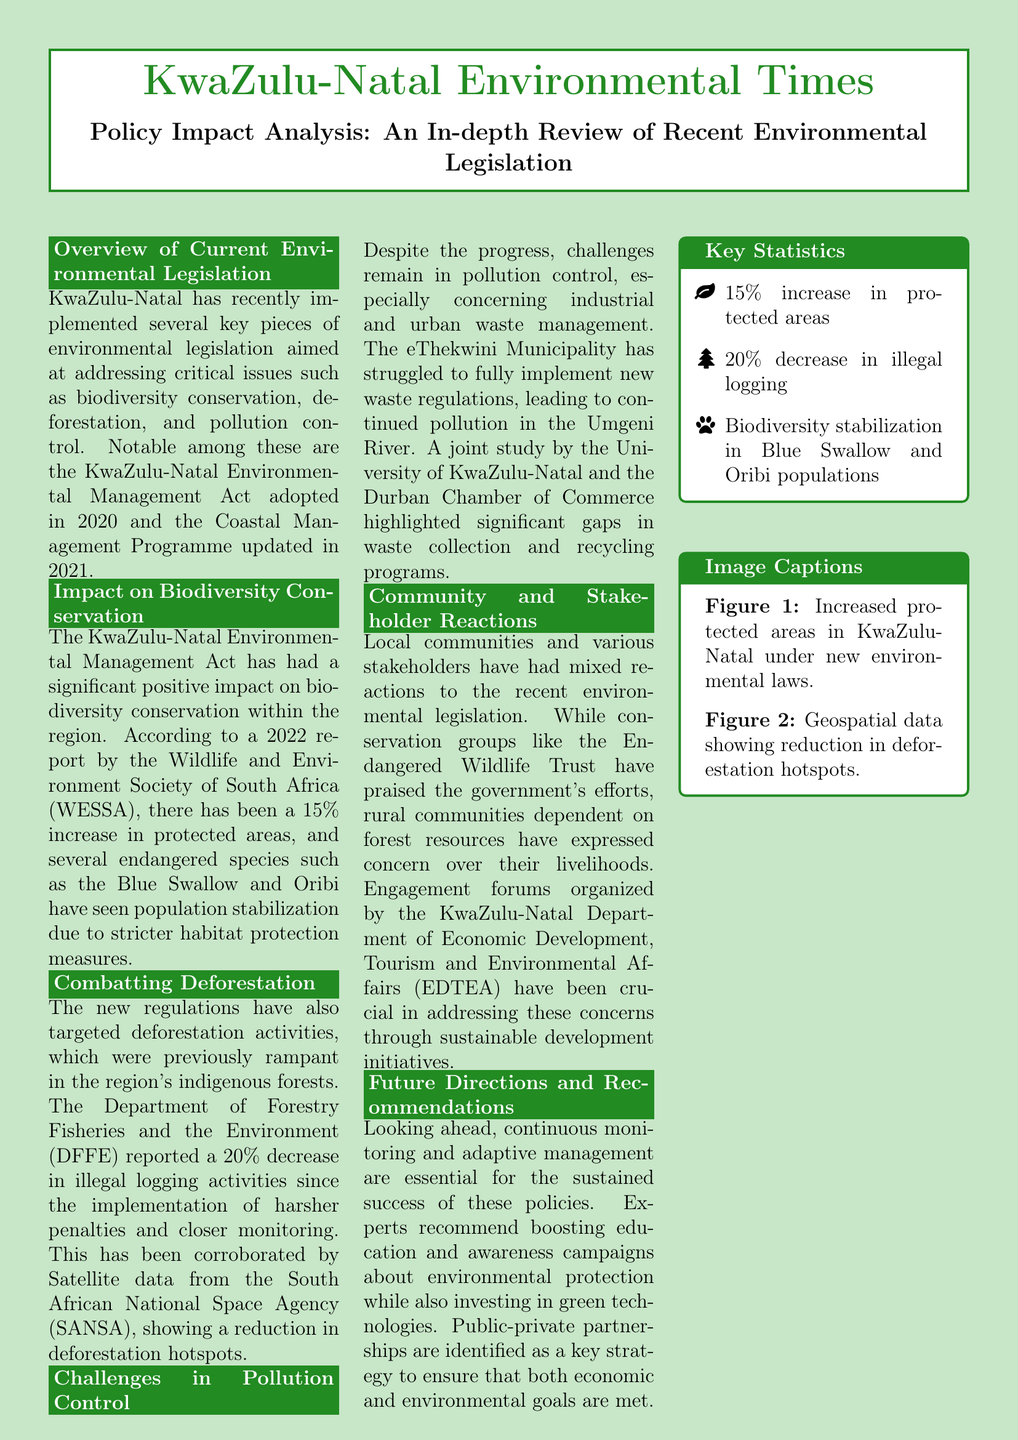What is the title of the analysis? The title of the analysis is found in the introduction section of the document.
Answer: Policy Impact Analysis: An In-depth Review of Recent Environmental Legislation What year was the KwaZulu-Natal Environmental Management Act adopted? The document states the year the act was adopted in the overview section.
Answer: 2020 What percentage increase in protected areas has been reported? The statistic is mentioned in the impact section regarding biodiversity conservation.
Answer: 15% Which two endangered species are mentioned regarding population stabilization? The document lists the species in the biodiversity conservation section.
Answer: Blue Swallow and Oribi What percentage decrease in illegal logging activities has been reported? This information is included under the combatting deforestation section of the document.
Answer: 20% What challenge is highlighted in pollution control? The document discusses the ongoing issues within a specific context in the pollution control section.
Answer: Industrial and urban waste management Which organization praised the government's efforts according to community reactions? The document mentions the organization that had a positive reaction in the community section.
Answer: Endangered Wildlife Trust What do experts recommend for future directions? The recommendations are summarized in the future directions and recommendations section, focusing on strategic approaches.
Answer: Education and awareness campaigns What image is associated with increased protected areas? The document presents a subtitle related to the image that corresponds with protected areas.
Answer: Figure 1 